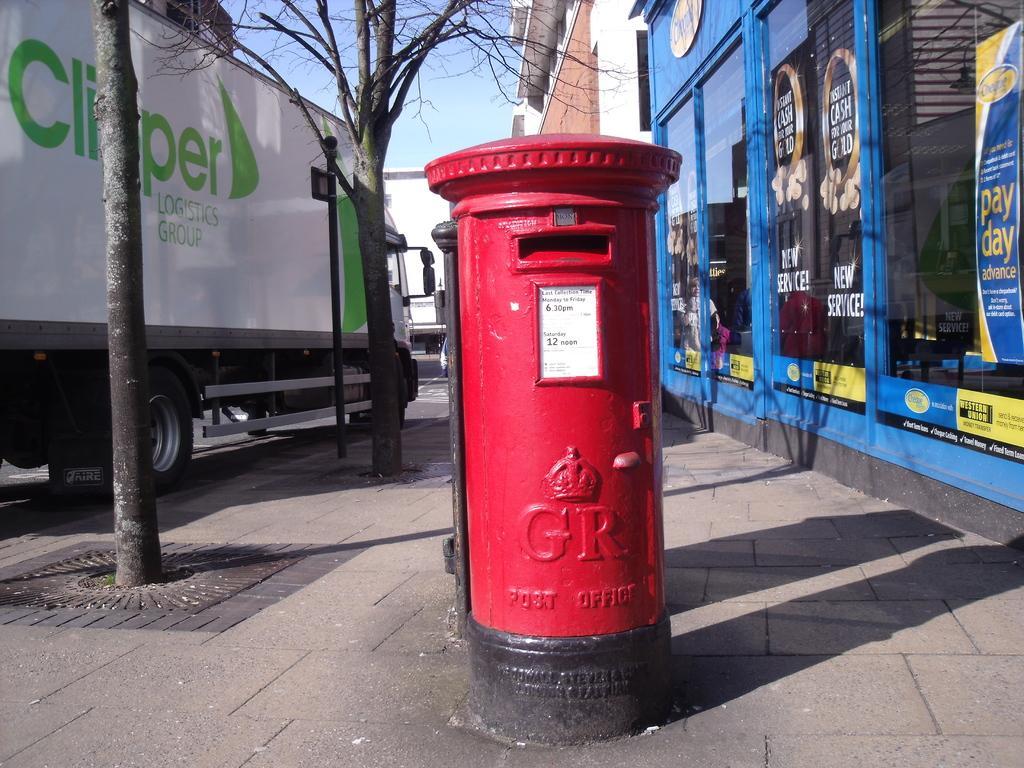Please provide a concise description of this image. This is the outside view of the city, in this image in the center there is one post box. And on the right side there are some buildings, glass windows and on the windows there are some posters. On the left side there is one vehicle and some trees and poles, in the background there are some buildings. At the top of the image there is sky, and at the bottom there is a footpath. 